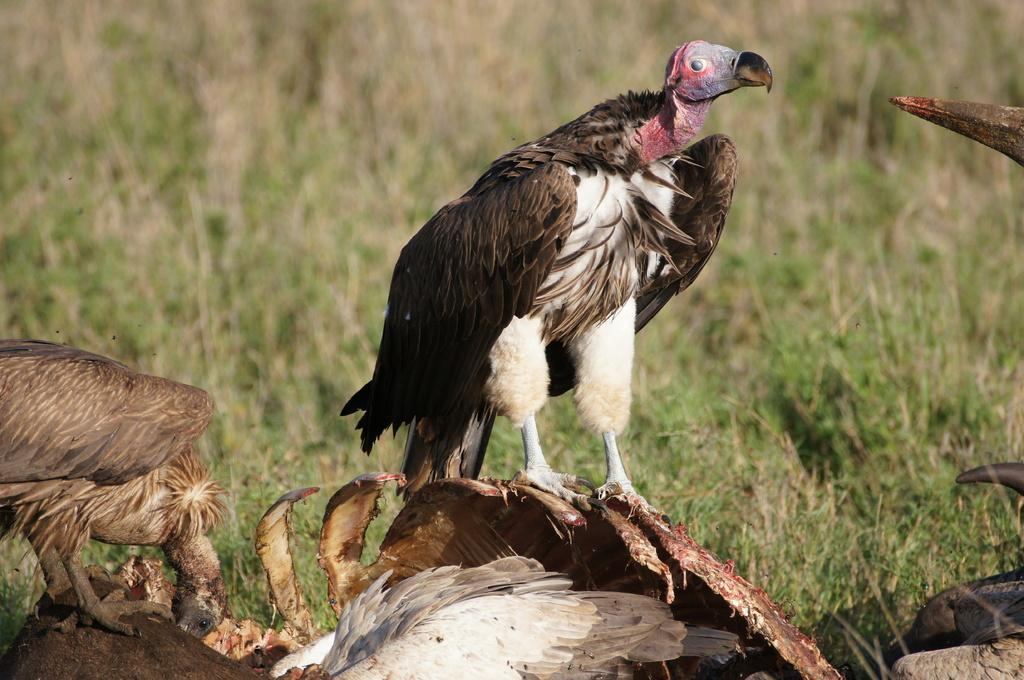What type of animals can be seen in the image? There are birds in the image. What is visible beneath the birds? The ground is visible in the image. Are there any objects on the ground? Yes, there are objects on the ground. What type of vegetation is present in the image? There is grass in the image. Where are the objects located in the image? There are objects on the right side of the image. Can you hear the banana crying in the image? There is no banana or crying sound present in the image. How many wings can be seen on the birds in the image? The number of wings on the birds cannot be determined from the image alone, as it depends on the type of bird. 